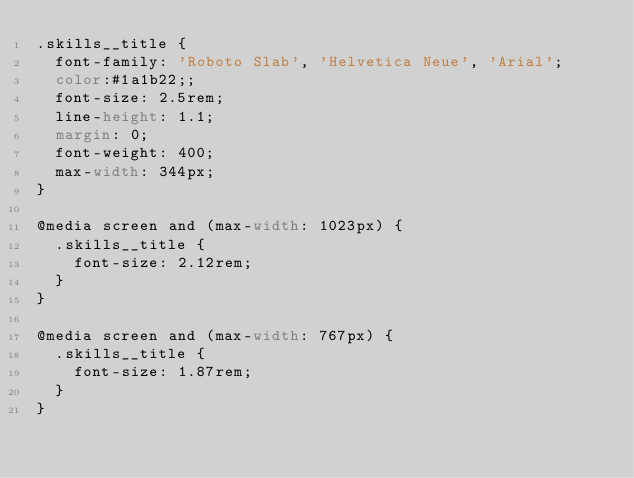<code> <loc_0><loc_0><loc_500><loc_500><_CSS_>.skills__title {
  font-family: 'Roboto Slab', 'Helvetica Neue', 'Arial';
  color:#1a1b22;;
  font-size: 2.5rem;
  line-height: 1.1;
  margin: 0;
  font-weight: 400;
  max-width: 344px;
}

@media screen and (max-width: 1023px) {
  .skills__title {
    font-size: 2.12rem;
  }
}

@media screen and (max-width: 767px) {
  .skills__title {
    font-size: 1.87rem;
  }
}
</code> 